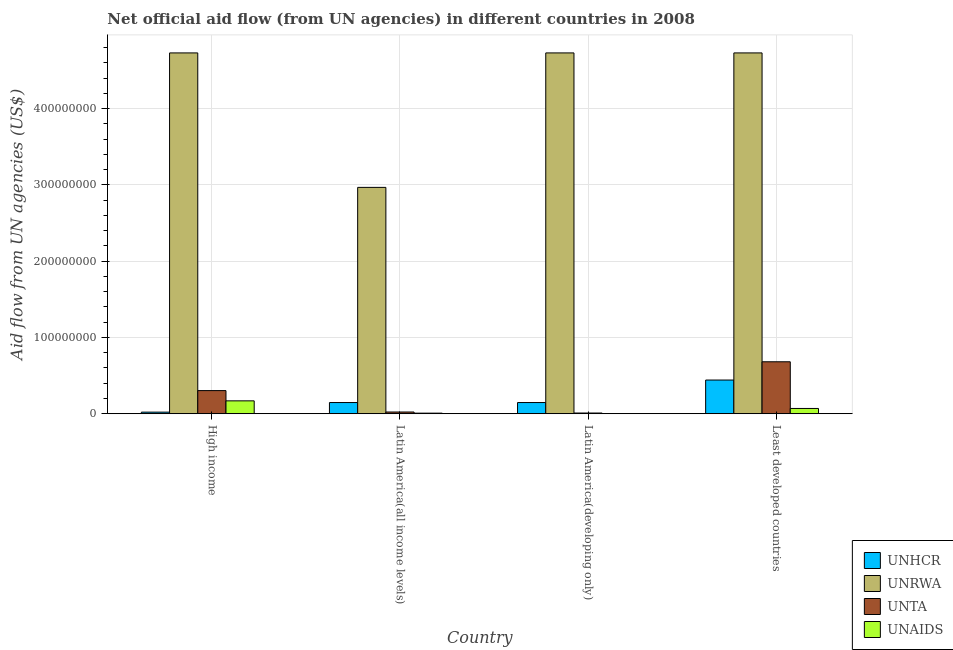How many different coloured bars are there?
Provide a succinct answer. 4. Are the number of bars on each tick of the X-axis equal?
Make the answer very short. Yes. What is the label of the 4th group of bars from the left?
Your answer should be compact. Least developed countries. What is the amount of aid given by unaids in Least developed countries?
Provide a succinct answer. 6.92e+06. Across all countries, what is the maximum amount of aid given by unaids?
Offer a terse response. 1.69e+07. Across all countries, what is the minimum amount of aid given by unaids?
Offer a terse response. 1.40e+05. In which country was the amount of aid given by unaids maximum?
Your response must be concise. High income. In which country was the amount of aid given by unrwa minimum?
Keep it short and to the point. Latin America(all income levels). What is the total amount of aid given by unhcr in the graph?
Your answer should be compact. 7.57e+07. What is the difference between the amount of aid given by unaids in High income and that in Latin America(all income levels)?
Provide a short and direct response. 1.61e+07. What is the difference between the amount of aid given by unhcr in Latin America(all income levels) and the amount of aid given by unta in Latin America(developing only)?
Make the answer very short. 1.38e+07. What is the average amount of aid given by unta per country?
Provide a succinct answer. 2.54e+07. What is the difference between the amount of aid given by unhcr and amount of aid given by unaids in Latin America(all income levels)?
Ensure brevity in your answer.  1.39e+07. In how many countries, is the amount of aid given by unhcr greater than 140000000 US$?
Offer a very short reply. 0. What is the ratio of the amount of aid given by unta in Latin America(developing only) to that in Least developed countries?
Make the answer very short. 0.01. Is the amount of aid given by unhcr in High income less than that in Latin America(developing only)?
Keep it short and to the point. Yes. Is the difference between the amount of aid given by unrwa in High income and Least developed countries greater than the difference between the amount of aid given by unaids in High income and Least developed countries?
Keep it short and to the point. No. What is the difference between the highest and the second highest amount of aid given by unta?
Give a very brief answer. 3.78e+07. What is the difference between the highest and the lowest amount of aid given by unrwa?
Provide a short and direct response. 1.76e+08. Is the sum of the amount of aid given by unhcr in Latin America(all income levels) and Latin America(developing only) greater than the maximum amount of aid given by unrwa across all countries?
Your response must be concise. No. Is it the case that in every country, the sum of the amount of aid given by unaids and amount of aid given by unhcr is greater than the sum of amount of aid given by unrwa and amount of aid given by unta?
Your response must be concise. No. What does the 3rd bar from the left in Latin America(all income levels) represents?
Offer a terse response. UNTA. What does the 3rd bar from the right in Latin America(all income levels) represents?
Give a very brief answer. UNRWA. How many countries are there in the graph?
Your answer should be compact. 4. What is the difference between two consecutive major ticks on the Y-axis?
Offer a terse response. 1.00e+08. Does the graph contain any zero values?
Keep it short and to the point. No. Does the graph contain grids?
Provide a short and direct response. Yes. Where does the legend appear in the graph?
Provide a short and direct response. Bottom right. How are the legend labels stacked?
Ensure brevity in your answer.  Vertical. What is the title of the graph?
Your answer should be compact. Net official aid flow (from UN agencies) in different countries in 2008. Does "Water" appear as one of the legend labels in the graph?
Provide a short and direct response. No. What is the label or title of the X-axis?
Your answer should be compact. Country. What is the label or title of the Y-axis?
Your answer should be very brief. Aid flow from UN agencies (US$). What is the Aid flow from UN agencies (US$) in UNHCR in High income?
Provide a succinct answer. 2.11e+06. What is the Aid flow from UN agencies (US$) in UNRWA in High income?
Your answer should be compact. 4.73e+08. What is the Aid flow from UN agencies (US$) in UNTA in High income?
Offer a terse response. 3.04e+07. What is the Aid flow from UN agencies (US$) of UNAIDS in High income?
Your answer should be very brief. 1.69e+07. What is the Aid flow from UN agencies (US$) of UNHCR in Latin America(all income levels)?
Offer a terse response. 1.47e+07. What is the Aid flow from UN agencies (US$) of UNRWA in Latin America(all income levels)?
Your answer should be compact. 2.97e+08. What is the Aid flow from UN agencies (US$) in UNTA in Latin America(all income levels)?
Provide a short and direct response. 2.26e+06. What is the Aid flow from UN agencies (US$) in UNAIDS in Latin America(all income levels)?
Provide a succinct answer. 7.80e+05. What is the Aid flow from UN agencies (US$) of UNHCR in Latin America(developing only)?
Keep it short and to the point. 1.47e+07. What is the Aid flow from UN agencies (US$) of UNRWA in Latin America(developing only)?
Ensure brevity in your answer.  4.73e+08. What is the Aid flow from UN agencies (US$) of UNTA in Latin America(developing only)?
Provide a short and direct response. 9.40e+05. What is the Aid flow from UN agencies (US$) of UNHCR in Least developed countries?
Keep it short and to the point. 4.42e+07. What is the Aid flow from UN agencies (US$) in UNRWA in Least developed countries?
Ensure brevity in your answer.  4.73e+08. What is the Aid flow from UN agencies (US$) in UNTA in Least developed countries?
Provide a succinct answer. 6.81e+07. What is the Aid flow from UN agencies (US$) of UNAIDS in Least developed countries?
Your response must be concise. 6.92e+06. Across all countries, what is the maximum Aid flow from UN agencies (US$) in UNHCR?
Provide a short and direct response. 4.42e+07. Across all countries, what is the maximum Aid flow from UN agencies (US$) of UNRWA?
Keep it short and to the point. 4.73e+08. Across all countries, what is the maximum Aid flow from UN agencies (US$) in UNTA?
Give a very brief answer. 6.81e+07. Across all countries, what is the maximum Aid flow from UN agencies (US$) in UNAIDS?
Ensure brevity in your answer.  1.69e+07. Across all countries, what is the minimum Aid flow from UN agencies (US$) in UNHCR?
Offer a very short reply. 2.11e+06. Across all countries, what is the minimum Aid flow from UN agencies (US$) of UNRWA?
Offer a terse response. 2.97e+08. Across all countries, what is the minimum Aid flow from UN agencies (US$) in UNTA?
Ensure brevity in your answer.  9.40e+05. What is the total Aid flow from UN agencies (US$) in UNHCR in the graph?
Make the answer very short. 7.57e+07. What is the total Aid flow from UN agencies (US$) in UNRWA in the graph?
Your response must be concise. 1.72e+09. What is the total Aid flow from UN agencies (US$) of UNTA in the graph?
Offer a very short reply. 1.02e+08. What is the total Aid flow from UN agencies (US$) of UNAIDS in the graph?
Your response must be concise. 2.47e+07. What is the difference between the Aid flow from UN agencies (US$) in UNHCR in High income and that in Latin America(all income levels)?
Give a very brief answer. -1.26e+07. What is the difference between the Aid flow from UN agencies (US$) in UNRWA in High income and that in Latin America(all income levels)?
Offer a very short reply. 1.76e+08. What is the difference between the Aid flow from UN agencies (US$) in UNTA in High income and that in Latin America(all income levels)?
Ensure brevity in your answer.  2.81e+07. What is the difference between the Aid flow from UN agencies (US$) of UNAIDS in High income and that in Latin America(all income levels)?
Offer a very short reply. 1.61e+07. What is the difference between the Aid flow from UN agencies (US$) in UNHCR in High income and that in Latin America(developing only)?
Your answer should be very brief. -1.26e+07. What is the difference between the Aid flow from UN agencies (US$) of UNRWA in High income and that in Latin America(developing only)?
Your answer should be very brief. 0. What is the difference between the Aid flow from UN agencies (US$) in UNTA in High income and that in Latin America(developing only)?
Offer a terse response. 2.94e+07. What is the difference between the Aid flow from UN agencies (US$) of UNAIDS in High income and that in Latin America(developing only)?
Provide a succinct answer. 1.68e+07. What is the difference between the Aid flow from UN agencies (US$) of UNHCR in High income and that in Least developed countries?
Your response must be concise. -4.21e+07. What is the difference between the Aid flow from UN agencies (US$) of UNRWA in High income and that in Least developed countries?
Make the answer very short. 0. What is the difference between the Aid flow from UN agencies (US$) of UNTA in High income and that in Least developed countries?
Give a very brief answer. -3.78e+07. What is the difference between the Aid flow from UN agencies (US$) of UNAIDS in High income and that in Least developed countries?
Your answer should be compact. 9.97e+06. What is the difference between the Aid flow from UN agencies (US$) of UNHCR in Latin America(all income levels) and that in Latin America(developing only)?
Give a very brief answer. 0. What is the difference between the Aid flow from UN agencies (US$) in UNRWA in Latin America(all income levels) and that in Latin America(developing only)?
Provide a succinct answer. -1.76e+08. What is the difference between the Aid flow from UN agencies (US$) in UNTA in Latin America(all income levels) and that in Latin America(developing only)?
Offer a terse response. 1.32e+06. What is the difference between the Aid flow from UN agencies (US$) in UNAIDS in Latin America(all income levels) and that in Latin America(developing only)?
Make the answer very short. 6.40e+05. What is the difference between the Aid flow from UN agencies (US$) of UNHCR in Latin America(all income levels) and that in Least developed countries?
Your answer should be very brief. -2.95e+07. What is the difference between the Aid flow from UN agencies (US$) of UNRWA in Latin America(all income levels) and that in Least developed countries?
Your response must be concise. -1.76e+08. What is the difference between the Aid flow from UN agencies (US$) of UNTA in Latin America(all income levels) and that in Least developed countries?
Provide a succinct answer. -6.59e+07. What is the difference between the Aid flow from UN agencies (US$) in UNAIDS in Latin America(all income levels) and that in Least developed countries?
Ensure brevity in your answer.  -6.14e+06. What is the difference between the Aid flow from UN agencies (US$) of UNHCR in Latin America(developing only) and that in Least developed countries?
Make the answer very short. -2.95e+07. What is the difference between the Aid flow from UN agencies (US$) of UNTA in Latin America(developing only) and that in Least developed countries?
Offer a very short reply. -6.72e+07. What is the difference between the Aid flow from UN agencies (US$) in UNAIDS in Latin America(developing only) and that in Least developed countries?
Make the answer very short. -6.78e+06. What is the difference between the Aid flow from UN agencies (US$) of UNHCR in High income and the Aid flow from UN agencies (US$) of UNRWA in Latin America(all income levels)?
Your answer should be very brief. -2.95e+08. What is the difference between the Aid flow from UN agencies (US$) in UNHCR in High income and the Aid flow from UN agencies (US$) in UNTA in Latin America(all income levels)?
Offer a very short reply. -1.50e+05. What is the difference between the Aid flow from UN agencies (US$) of UNHCR in High income and the Aid flow from UN agencies (US$) of UNAIDS in Latin America(all income levels)?
Your response must be concise. 1.33e+06. What is the difference between the Aid flow from UN agencies (US$) in UNRWA in High income and the Aid flow from UN agencies (US$) in UNTA in Latin America(all income levels)?
Your answer should be very brief. 4.71e+08. What is the difference between the Aid flow from UN agencies (US$) of UNRWA in High income and the Aid flow from UN agencies (US$) of UNAIDS in Latin America(all income levels)?
Keep it short and to the point. 4.72e+08. What is the difference between the Aid flow from UN agencies (US$) of UNTA in High income and the Aid flow from UN agencies (US$) of UNAIDS in Latin America(all income levels)?
Your answer should be compact. 2.96e+07. What is the difference between the Aid flow from UN agencies (US$) of UNHCR in High income and the Aid flow from UN agencies (US$) of UNRWA in Latin America(developing only)?
Provide a short and direct response. -4.71e+08. What is the difference between the Aid flow from UN agencies (US$) of UNHCR in High income and the Aid flow from UN agencies (US$) of UNTA in Latin America(developing only)?
Your response must be concise. 1.17e+06. What is the difference between the Aid flow from UN agencies (US$) of UNHCR in High income and the Aid flow from UN agencies (US$) of UNAIDS in Latin America(developing only)?
Give a very brief answer. 1.97e+06. What is the difference between the Aid flow from UN agencies (US$) in UNRWA in High income and the Aid flow from UN agencies (US$) in UNTA in Latin America(developing only)?
Make the answer very short. 4.72e+08. What is the difference between the Aid flow from UN agencies (US$) in UNRWA in High income and the Aid flow from UN agencies (US$) in UNAIDS in Latin America(developing only)?
Provide a short and direct response. 4.73e+08. What is the difference between the Aid flow from UN agencies (US$) in UNTA in High income and the Aid flow from UN agencies (US$) in UNAIDS in Latin America(developing only)?
Your answer should be compact. 3.02e+07. What is the difference between the Aid flow from UN agencies (US$) of UNHCR in High income and the Aid flow from UN agencies (US$) of UNRWA in Least developed countries?
Ensure brevity in your answer.  -4.71e+08. What is the difference between the Aid flow from UN agencies (US$) of UNHCR in High income and the Aid flow from UN agencies (US$) of UNTA in Least developed countries?
Offer a very short reply. -6.60e+07. What is the difference between the Aid flow from UN agencies (US$) in UNHCR in High income and the Aid flow from UN agencies (US$) in UNAIDS in Least developed countries?
Ensure brevity in your answer.  -4.81e+06. What is the difference between the Aid flow from UN agencies (US$) of UNRWA in High income and the Aid flow from UN agencies (US$) of UNTA in Least developed countries?
Give a very brief answer. 4.05e+08. What is the difference between the Aid flow from UN agencies (US$) of UNRWA in High income and the Aid flow from UN agencies (US$) of UNAIDS in Least developed countries?
Your answer should be compact. 4.66e+08. What is the difference between the Aid flow from UN agencies (US$) of UNTA in High income and the Aid flow from UN agencies (US$) of UNAIDS in Least developed countries?
Your response must be concise. 2.34e+07. What is the difference between the Aid flow from UN agencies (US$) in UNHCR in Latin America(all income levels) and the Aid flow from UN agencies (US$) in UNRWA in Latin America(developing only)?
Ensure brevity in your answer.  -4.58e+08. What is the difference between the Aid flow from UN agencies (US$) in UNHCR in Latin America(all income levels) and the Aid flow from UN agencies (US$) in UNTA in Latin America(developing only)?
Make the answer very short. 1.38e+07. What is the difference between the Aid flow from UN agencies (US$) of UNHCR in Latin America(all income levels) and the Aid flow from UN agencies (US$) of UNAIDS in Latin America(developing only)?
Provide a short and direct response. 1.46e+07. What is the difference between the Aid flow from UN agencies (US$) in UNRWA in Latin America(all income levels) and the Aid flow from UN agencies (US$) in UNTA in Latin America(developing only)?
Offer a terse response. 2.96e+08. What is the difference between the Aid flow from UN agencies (US$) of UNRWA in Latin America(all income levels) and the Aid flow from UN agencies (US$) of UNAIDS in Latin America(developing only)?
Make the answer very short. 2.97e+08. What is the difference between the Aid flow from UN agencies (US$) of UNTA in Latin America(all income levels) and the Aid flow from UN agencies (US$) of UNAIDS in Latin America(developing only)?
Ensure brevity in your answer.  2.12e+06. What is the difference between the Aid flow from UN agencies (US$) in UNHCR in Latin America(all income levels) and the Aid flow from UN agencies (US$) in UNRWA in Least developed countries?
Offer a terse response. -4.58e+08. What is the difference between the Aid flow from UN agencies (US$) of UNHCR in Latin America(all income levels) and the Aid flow from UN agencies (US$) of UNTA in Least developed countries?
Your response must be concise. -5.34e+07. What is the difference between the Aid flow from UN agencies (US$) in UNHCR in Latin America(all income levels) and the Aid flow from UN agencies (US$) in UNAIDS in Least developed countries?
Give a very brief answer. 7.77e+06. What is the difference between the Aid flow from UN agencies (US$) of UNRWA in Latin America(all income levels) and the Aid flow from UN agencies (US$) of UNTA in Least developed countries?
Your answer should be very brief. 2.29e+08. What is the difference between the Aid flow from UN agencies (US$) of UNRWA in Latin America(all income levels) and the Aid flow from UN agencies (US$) of UNAIDS in Least developed countries?
Offer a terse response. 2.90e+08. What is the difference between the Aid flow from UN agencies (US$) of UNTA in Latin America(all income levels) and the Aid flow from UN agencies (US$) of UNAIDS in Least developed countries?
Make the answer very short. -4.66e+06. What is the difference between the Aid flow from UN agencies (US$) in UNHCR in Latin America(developing only) and the Aid flow from UN agencies (US$) in UNRWA in Least developed countries?
Ensure brevity in your answer.  -4.58e+08. What is the difference between the Aid flow from UN agencies (US$) in UNHCR in Latin America(developing only) and the Aid flow from UN agencies (US$) in UNTA in Least developed countries?
Your answer should be very brief. -5.34e+07. What is the difference between the Aid flow from UN agencies (US$) of UNHCR in Latin America(developing only) and the Aid flow from UN agencies (US$) of UNAIDS in Least developed countries?
Provide a short and direct response. 7.77e+06. What is the difference between the Aid flow from UN agencies (US$) in UNRWA in Latin America(developing only) and the Aid flow from UN agencies (US$) in UNTA in Least developed countries?
Make the answer very short. 4.05e+08. What is the difference between the Aid flow from UN agencies (US$) of UNRWA in Latin America(developing only) and the Aid flow from UN agencies (US$) of UNAIDS in Least developed countries?
Give a very brief answer. 4.66e+08. What is the difference between the Aid flow from UN agencies (US$) of UNTA in Latin America(developing only) and the Aid flow from UN agencies (US$) of UNAIDS in Least developed countries?
Keep it short and to the point. -5.98e+06. What is the average Aid flow from UN agencies (US$) in UNHCR per country?
Provide a short and direct response. 1.89e+07. What is the average Aid flow from UN agencies (US$) of UNRWA per country?
Offer a very short reply. 4.29e+08. What is the average Aid flow from UN agencies (US$) of UNTA per country?
Keep it short and to the point. 2.54e+07. What is the average Aid flow from UN agencies (US$) of UNAIDS per country?
Keep it short and to the point. 6.18e+06. What is the difference between the Aid flow from UN agencies (US$) in UNHCR and Aid flow from UN agencies (US$) in UNRWA in High income?
Give a very brief answer. -4.71e+08. What is the difference between the Aid flow from UN agencies (US$) of UNHCR and Aid flow from UN agencies (US$) of UNTA in High income?
Make the answer very short. -2.82e+07. What is the difference between the Aid flow from UN agencies (US$) of UNHCR and Aid flow from UN agencies (US$) of UNAIDS in High income?
Give a very brief answer. -1.48e+07. What is the difference between the Aid flow from UN agencies (US$) of UNRWA and Aid flow from UN agencies (US$) of UNTA in High income?
Offer a very short reply. 4.43e+08. What is the difference between the Aid flow from UN agencies (US$) in UNRWA and Aid flow from UN agencies (US$) in UNAIDS in High income?
Your answer should be compact. 4.56e+08. What is the difference between the Aid flow from UN agencies (US$) in UNTA and Aid flow from UN agencies (US$) in UNAIDS in High income?
Give a very brief answer. 1.35e+07. What is the difference between the Aid flow from UN agencies (US$) of UNHCR and Aid flow from UN agencies (US$) of UNRWA in Latin America(all income levels)?
Offer a very short reply. -2.82e+08. What is the difference between the Aid flow from UN agencies (US$) of UNHCR and Aid flow from UN agencies (US$) of UNTA in Latin America(all income levels)?
Provide a short and direct response. 1.24e+07. What is the difference between the Aid flow from UN agencies (US$) of UNHCR and Aid flow from UN agencies (US$) of UNAIDS in Latin America(all income levels)?
Your response must be concise. 1.39e+07. What is the difference between the Aid flow from UN agencies (US$) in UNRWA and Aid flow from UN agencies (US$) in UNTA in Latin America(all income levels)?
Your answer should be compact. 2.95e+08. What is the difference between the Aid flow from UN agencies (US$) in UNRWA and Aid flow from UN agencies (US$) in UNAIDS in Latin America(all income levels)?
Ensure brevity in your answer.  2.96e+08. What is the difference between the Aid flow from UN agencies (US$) of UNTA and Aid flow from UN agencies (US$) of UNAIDS in Latin America(all income levels)?
Offer a very short reply. 1.48e+06. What is the difference between the Aid flow from UN agencies (US$) of UNHCR and Aid flow from UN agencies (US$) of UNRWA in Latin America(developing only)?
Your answer should be very brief. -4.58e+08. What is the difference between the Aid flow from UN agencies (US$) of UNHCR and Aid flow from UN agencies (US$) of UNTA in Latin America(developing only)?
Offer a very short reply. 1.38e+07. What is the difference between the Aid flow from UN agencies (US$) in UNHCR and Aid flow from UN agencies (US$) in UNAIDS in Latin America(developing only)?
Provide a succinct answer. 1.46e+07. What is the difference between the Aid flow from UN agencies (US$) of UNRWA and Aid flow from UN agencies (US$) of UNTA in Latin America(developing only)?
Offer a very short reply. 4.72e+08. What is the difference between the Aid flow from UN agencies (US$) in UNRWA and Aid flow from UN agencies (US$) in UNAIDS in Latin America(developing only)?
Provide a succinct answer. 4.73e+08. What is the difference between the Aid flow from UN agencies (US$) of UNHCR and Aid flow from UN agencies (US$) of UNRWA in Least developed countries?
Give a very brief answer. -4.29e+08. What is the difference between the Aid flow from UN agencies (US$) of UNHCR and Aid flow from UN agencies (US$) of UNTA in Least developed countries?
Your response must be concise. -2.39e+07. What is the difference between the Aid flow from UN agencies (US$) in UNHCR and Aid flow from UN agencies (US$) in UNAIDS in Least developed countries?
Offer a very short reply. 3.73e+07. What is the difference between the Aid flow from UN agencies (US$) in UNRWA and Aid flow from UN agencies (US$) in UNTA in Least developed countries?
Make the answer very short. 4.05e+08. What is the difference between the Aid flow from UN agencies (US$) of UNRWA and Aid flow from UN agencies (US$) of UNAIDS in Least developed countries?
Offer a terse response. 4.66e+08. What is the difference between the Aid flow from UN agencies (US$) in UNTA and Aid flow from UN agencies (US$) in UNAIDS in Least developed countries?
Keep it short and to the point. 6.12e+07. What is the ratio of the Aid flow from UN agencies (US$) in UNHCR in High income to that in Latin America(all income levels)?
Your response must be concise. 0.14. What is the ratio of the Aid flow from UN agencies (US$) in UNRWA in High income to that in Latin America(all income levels)?
Offer a terse response. 1.59. What is the ratio of the Aid flow from UN agencies (US$) of UNTA in High income to that in Latin America(all income levels)?
Your response must be concise. 13.43. What is the ratio of the Aid flow from UN agencies (US$) of UNAIDS in High income to that in Latin America(all income levels)?
Ensure brevity in your answer.  21.65. What is the ratio of the Aid flow from UN agencies (US$) in UNHCR in High income to that in Latin America(developing only)?
Offer a very short reply. 0.14. What is the ratio of the Aid flow from UN agencies (US$) in UNTA in High income to that in Latin America(developing only)?
Provide a short and direct response. 32.29. What is the ratio of the Aid flow from UN agencies (US$) of UNAIDS in High income to that in Latin America(developing only)?
Offer a very short reply. 120.64. What is the ratio of the Aid flow from UN agencies (US$) in UNHCR in High income to that in Least developed countries?
Offer a terse response. 0.05. What is the ratio of the Aid flow from UN agencies (US$) in UNRWA in High income to that in Least developed countries?
Your response must be concise. 1. What is the ratio of the Aid flow from UN agencies (US$) of UNTA in High income to that in Least developed countries?
Your answer should be very brief. 0.45. What is the ratio of the Aid flow from UN agencies (US$) of UNAIDS in High income to that in Least developed countries?
Ensure brevity in your answer.  2.44. What is the ratio of the Aid flow from UN agencies (US$) of UNRWA in Latin America(all income levels) to that in Latin America(developing only)?
Your answer should be compact. 0.63. What is the ratio of the Aid flow from UN agencies (US$) of UNTA in Latin America(all income levels) to that in Latin America(developing only)?
Make the answer very short. 2.4. What is the ratio of the Aid flow from UN agencies (US$) of UNAIDS in Latin America(all income levels) to that in Latin America(developing only)?
Give a very brief answer. 5.57. What is the ratio of the Aid flow from UN agencies (US$) of UNHCR in Latin America(all income levels) to that in Least developed countries?
Provide a short and direct response. 0.33. What is the ratio of the Aid flow from UN agencies (US$) in UNRWA in Latin America(all income levels) to that in Least developed countries?
Your response must be concise. 0.63. What is the ratio of the Aid flow from UN agencies (US$) in UNTA in Latin America(all income levels) to that in Least developed countries?
Offer a very short reply. 0.03. What is the ratio of the Aid flow from UN agencies (US$) of UNAIDS in Latin America(all income levels) to that in Least developed countries?
Keep it short and to the point. 0.11. What is the ratio of the Aid flow from UN agencies (US$) in UNHCR in Latin America(developing only) to that in Least developed countries?
Offer a very short reply. 0.33. What is the ratio of the Aid flow from UN agencies (US$) in UNTA in Latin America(developing only) to that in Least developed countries?
Offer a very short reply. 0.01. What is the ratio of the Aid flow from UN agencies (US$) in UNAIDS in Latin America(developing only) to that in Least developed countries?
Provide a short and direct response. 0.02. What is the difference between the highest and the second highest Aid flow from UN agencies (US$) in UNHCR?
Your answer should be compact. 2.95e+07. What is the difference between the highest and the second highest Aid flow from UN agencies (US$) of UNRWA?
Keep it short and to the point. 0. What is the difference between the highest and the second highest Aid flow from UN agencies (US$) of UNTA?
Give a very brief answer. 3.78e+07. What is the difference between the highest and the second highest Aid flow from UN agencies (US$) of UNAIDS?
Your answer should be compact. 9.97e+06. What is the difference between the highest and the lowest Aid flow from UN agencies (US$) of UNHCR?
Offer a very short reply. 4.21e+07. What is the difference between the highest and the lowest Aid flow from UN agencies (US$) of UNRWA?
Your response must be concise. 1.76e+08. What is the difference between the highest and the lowest Aid flow from UN agencies (US$) of UNTA?
Provide a succinct answer. 6.72e+07. What is the difference between the highest and the lowest Aid flow from UN agencies (US$) in UNAIDS?
Provide a short and direct response. 1.68e+07. 